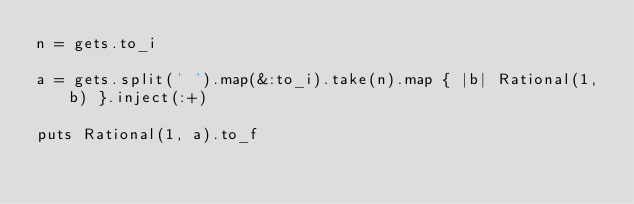<code> <loc_0><loc_0><loc_500><loc_500><_Ruby_>n = gets.to_i

a = gets.split(' ').map(&:to_i).take(n).map { |b| Rational(1, b) }.inject(:+)

puts Rational(1, a).to_f</code> 